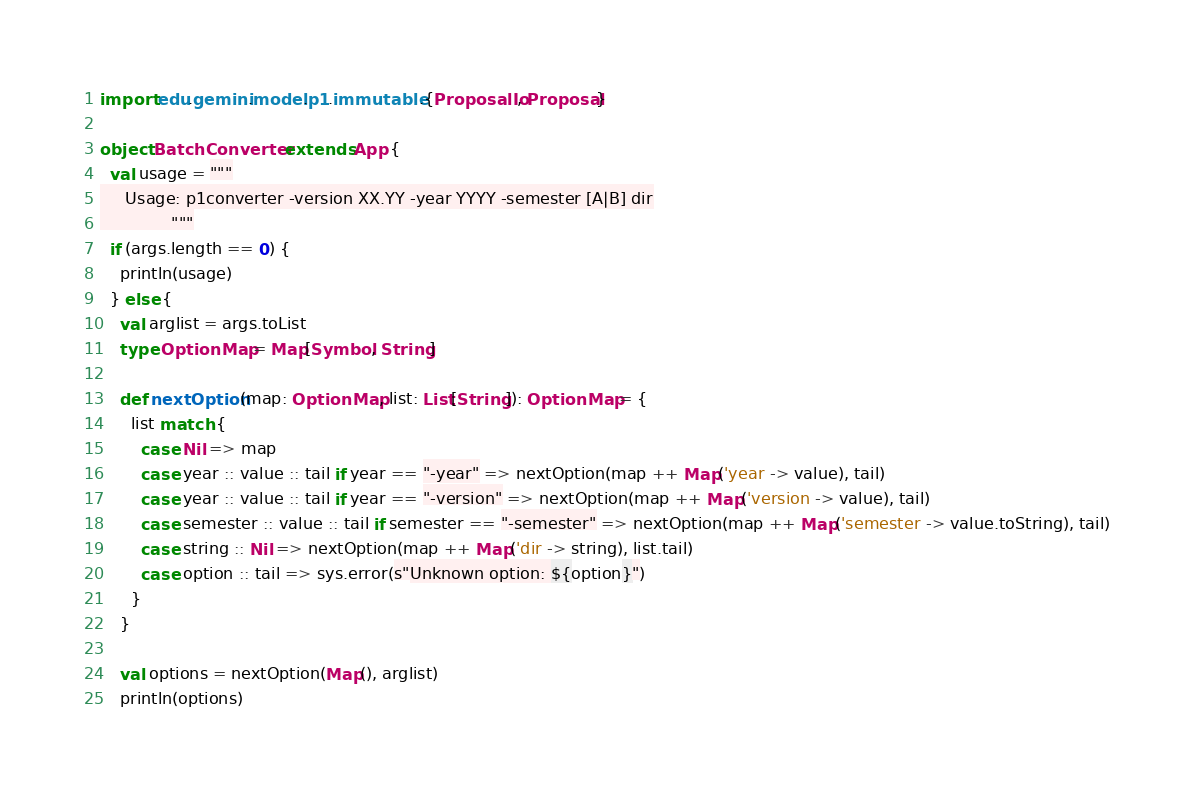Convert code to text. <code><loc_0><loc_0><loc_500><loc_500><_Scala_>import edu.gemini.model.p1.immutable.{ProposalIo, Proposal}

object BatchConverter extends App {
  val usage = """
     Usage: p1converter -version XX.YY -year YYYY -semester [A|B] dir
              """
  if (args.length == 0) {
    println(usage)
  } else {
    val arglist = args.toList
    type OptionMap = Map[Symbol, String]

    def nextOption(map: OptionMap, list: List[String]): OptionMap = {
      list match {
        case Nil => map
        case year :: value :: tail if year == "-year" => nextOption(map ++ Map('year -> value), tail)
        case year :: value :: tail if year == "-version" => nextOption(map ++ Map('version -> value), tail)
        case semester :: value :: tail if semester == "-semester" => nextOption(map ++ Map('semester -> value.toString), tail)
        case string :: Nil => nextOption(map ++ Map('dir -> string), list.tail)
        case option :: tail => sys.error(s"Unknown option: ${option}")
      }
    }

    val options = nextOption(Map(), arglist)
    println(options)</code> 